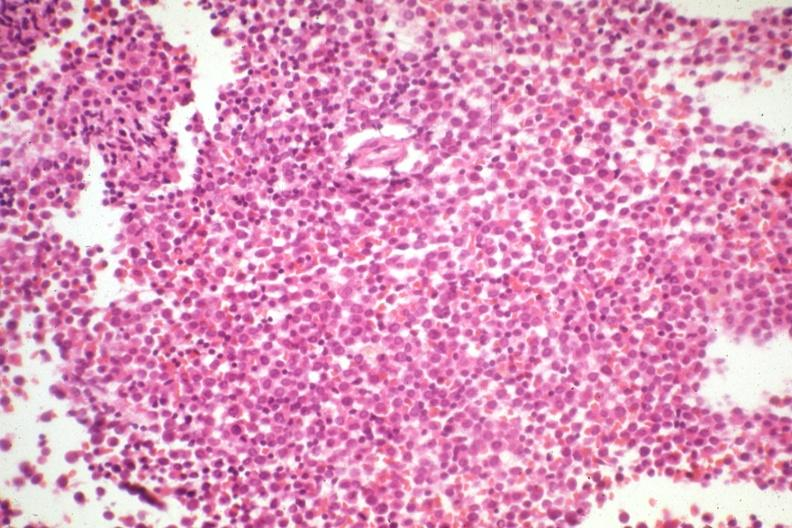what had not knocked out leukemia cells?
Answer the question using a single word or phrase. This therapy 